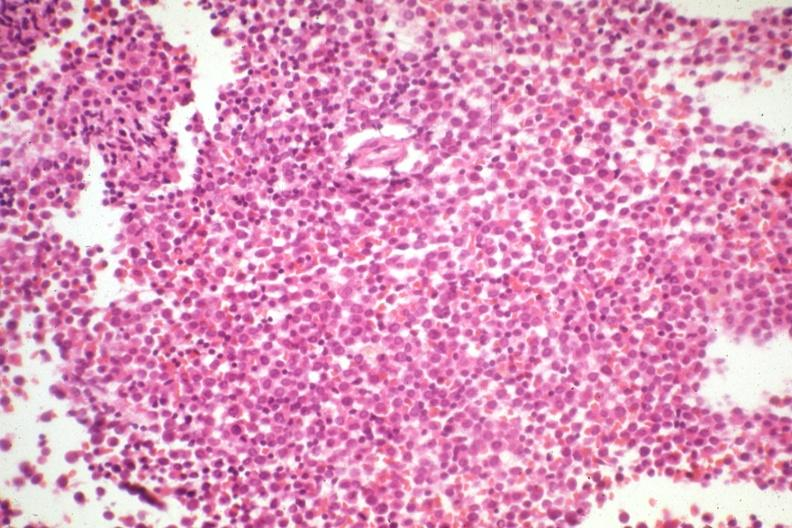what had not knocked out leukemia cells?
Answer the question using a single word or phrase. This therapy 